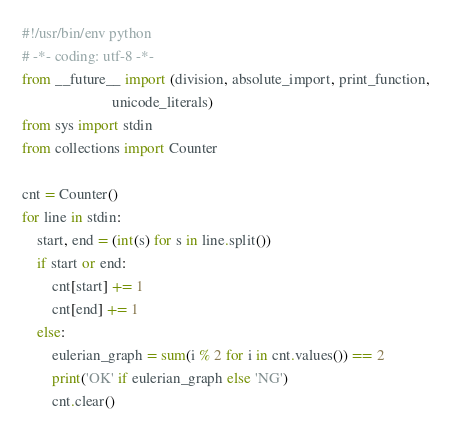Convert code to text. <code><loc_0><loc_0><loc_500><loc_500><_Python_>#!/usr/bin/env python
# -*- coding: utf-8 -*-
from __future__ import (division, absolute_import, print_function,
                        unicode_literals)
from sys import stdin
from collections import Counter

cnt = Counter()
for line in stdin:
    start, end = (int(s) for s in line.split())
    if start or end:
        cnt[start] += 1
        cnt[end] += 1
    else:
        eulerian_graph = sum(i % 2 for i in cnt.values()) == 2
        print('OK' if eulerian_graph else 'NG')
        cnt.clear()</code> 